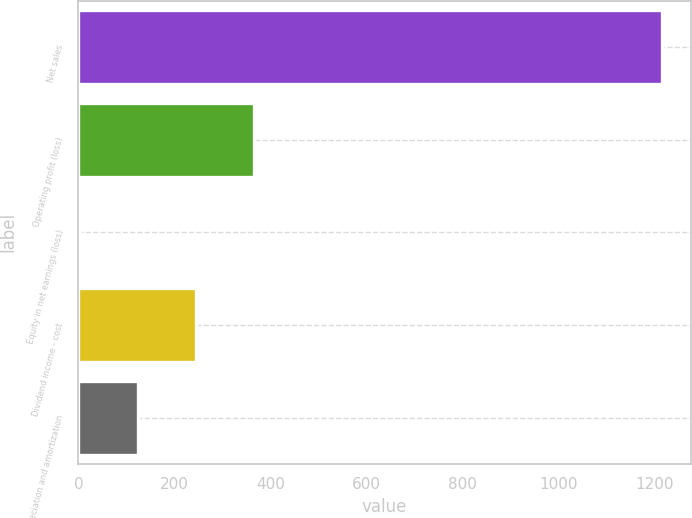Convert chart to OTSL. <chart><loc_0><loc_0><loc_500><loc_500><bar_chart><fcel>Net sales<fcel>Operating profit (loss)<fcel>Equity in net earnings (loss)<fcel>Dividend income - cost<fcel>Depreciation and amortization<nl><fcel>1214<fcel>366.3<fcel>3<fcel>245.2<fcel>124.1<nl></chart> 